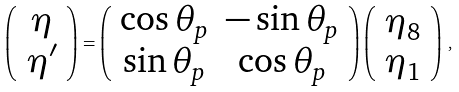Convert formula to latex. <formula><loc_0><loc_0><loc_500><loc_500>\left ( \begin{array} { c } \eta \\ \eta ^ { \prime } \end{array} \right ) = \left ( \begin{array} { c c } \cos { \theta _ { p } } & - \sin { \theta _ { p } } \\ \sin { \theta _ { p } } & \cos { \theta _ { p } } \\ \end{array} \right ) \left ( \begin{array} { c } \eta _ { 8 } \\ \eta _ { 1 } \\ \end{array} \right ) \, ,</formula> 